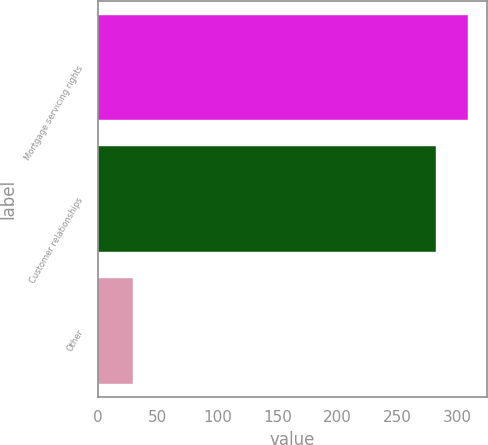Convert chart to OTSL. <chart><loc_0><loc_0><loc_500><loc_500><bar_chart><fcel>Mortgage servicing rights<fcel>Customer relationships<fcel>Other<nl><fcel>308.7<fcel>282<fcel>29<nl></chart> 